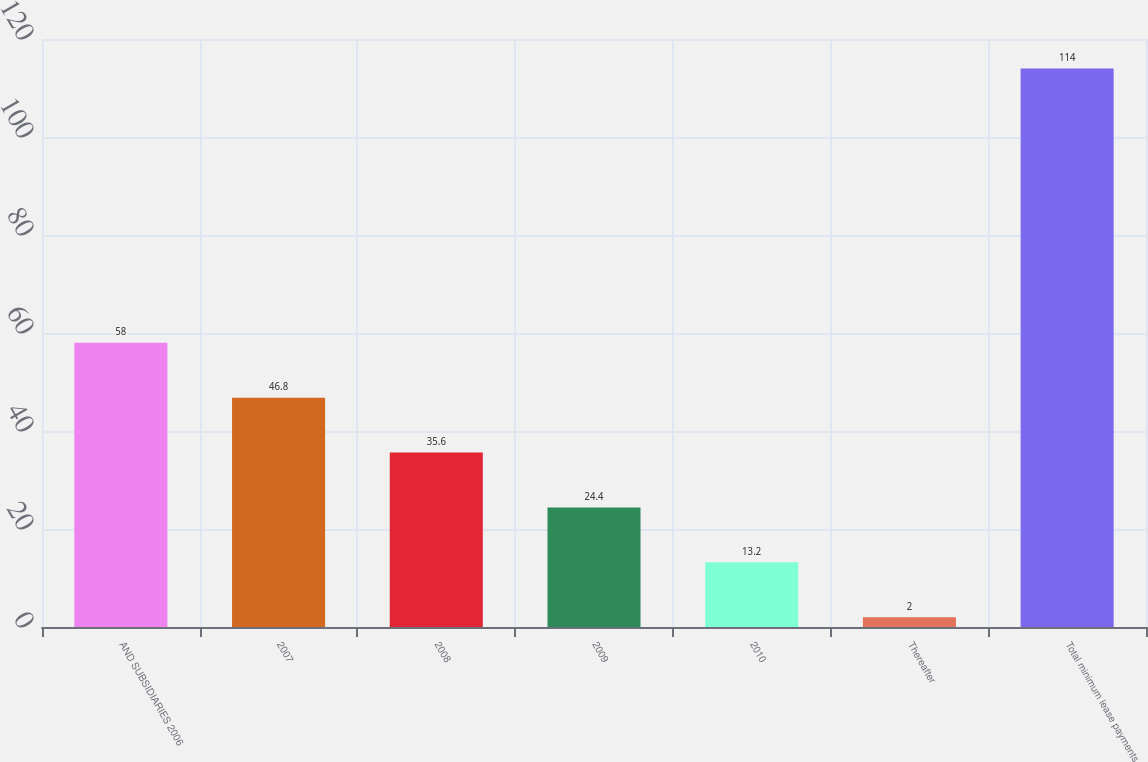<chart> <loc_0><loc_0><loc_500><loc_500><bar_chart><fcel>AND SUBSIDIARIES 2006<fcel>2007<fcel>2008<fcel>2009<fcel>2010<fcel>Thereafter<fcel>Total minimum lease payments<nl><fcel>58<fcel>46.8<fcel>35.6<fcel>24.4<fcel>13.2<fcel>2<fcel>114<nl></chart> 